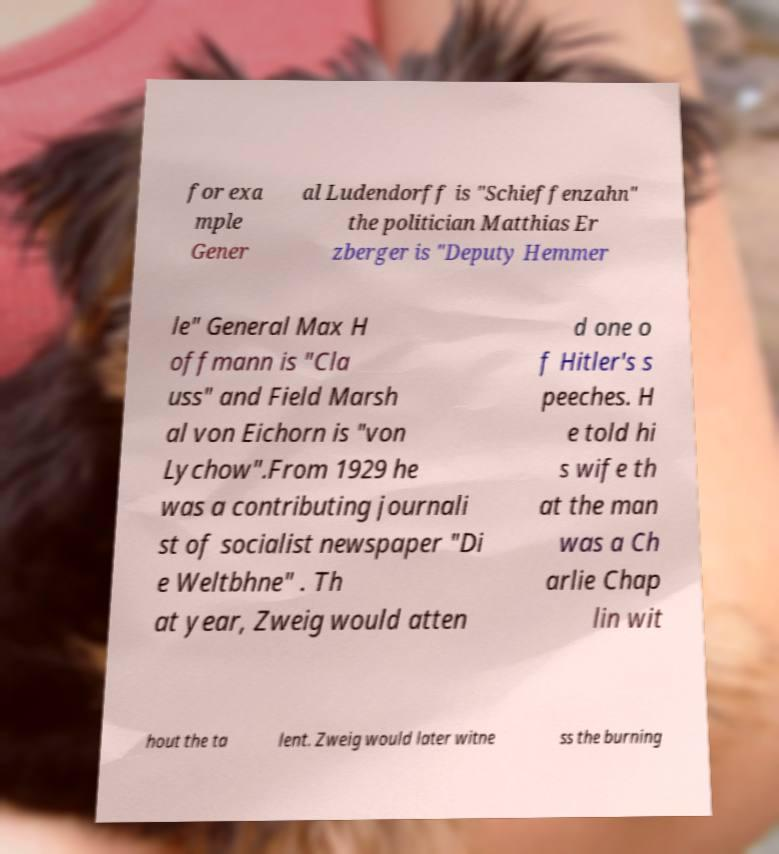There's text embedded in this image that I need extracted. Can you transcribe it verbatim? for exa mple Gener al Ludendorff is "Schieffenzahn" the politician Matthias Er zberger is "Deputy Hemmer le" General Max H offmann is "Cla uss" and Field Marsh al von Eichorn is "von Lychow".From 1929 he was a contributing journali st of socialist newspaper "Di e Weltbhne" . Th at year, Zweig would atten d one o f Hitler's s peeches. H e told hi s wife th at the man was a Ch arlie Chap lin wit hout the ta lent. Zweig would later witne ss the burning 